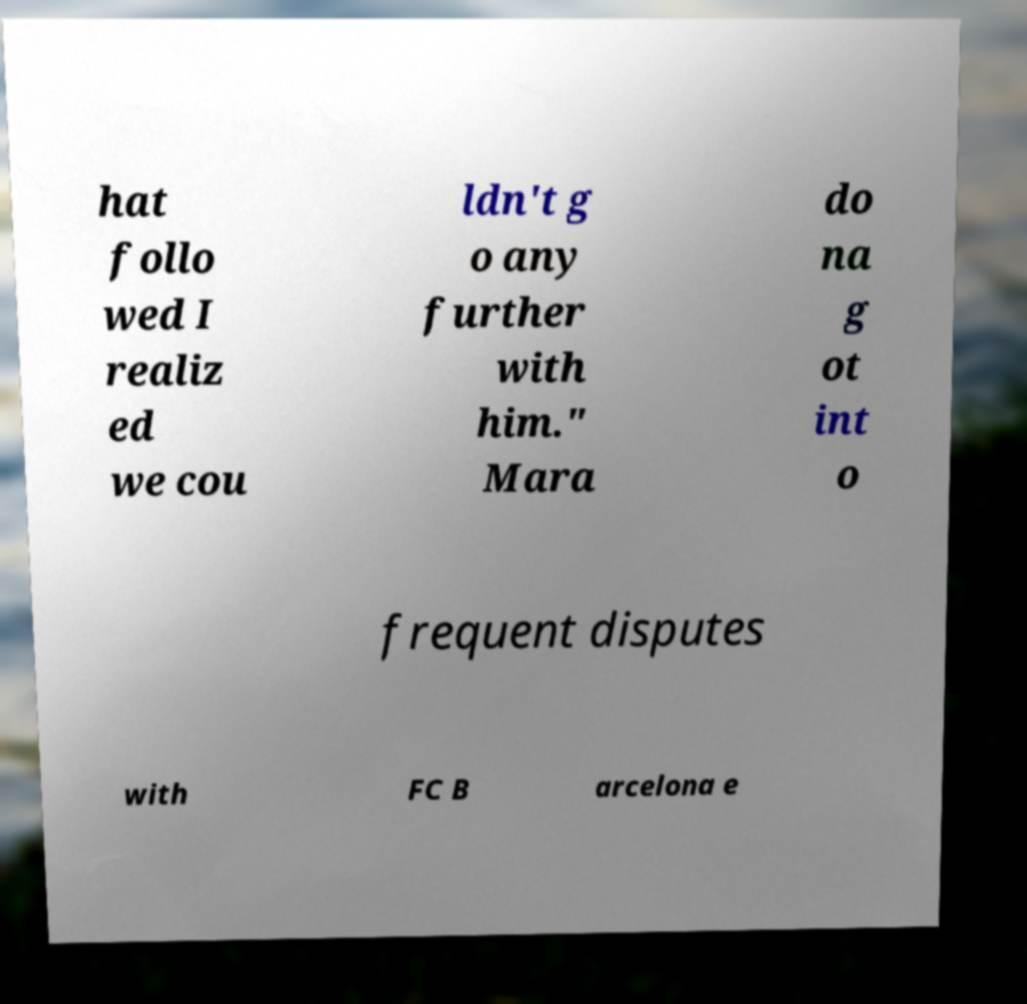Could you extract and type out the text from this image? hat follo wed I realiz ed we cou ldn't g o any further with him." Mara do na g ot int o frequent disputes with FC B arcelona e 